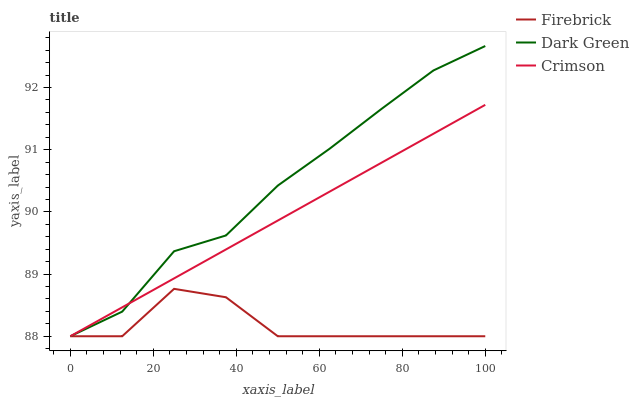Does Firebrick have the minimum area under the curve?
Answer yes or no. Yes. Does Dark Green have the maximum area under the curve?
Answer yes or no. Yes. Does Dark Green have the minimum area under the curve?
Answer yes or no. No. Does Firebrick have the maximum area under the curve?
Answer yes or no. No. Is Crimson the smoothest?
Answer yes or no. Yes. Is Firebrick the roughest?
Answer yes or no. Yes. Is Dark Green the smoothest?
Answer yes or no. No. Is Dark Green the roughest?
Answer yes or no. No. Does Crimson have the lowest value?
Answer yes or no. Yes. Does Dark Green have the highest value?
Answer yes or no. Yes. Does Firebrick have the highest value?
Answer yes or no. No. Does Crimson intersect Dark Green?
Answer yes or no. Yes. Is Crimson less than Dark Green?
Answer yes or no. No. Is Crimson greater than Dark Green?
Answer yes or no. No. 